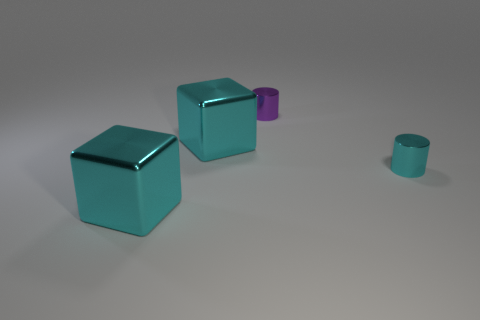There is a cube that is behind the tiny shiny thing right of the small purple metallic thing; what color is it? The cube located behind the tiny shiny object, which is to the right of the small purple metallic item, is cyan in color. Its reflective surface gives off a subtle gleam under the lighting, emphasizing its vibrant hue. 